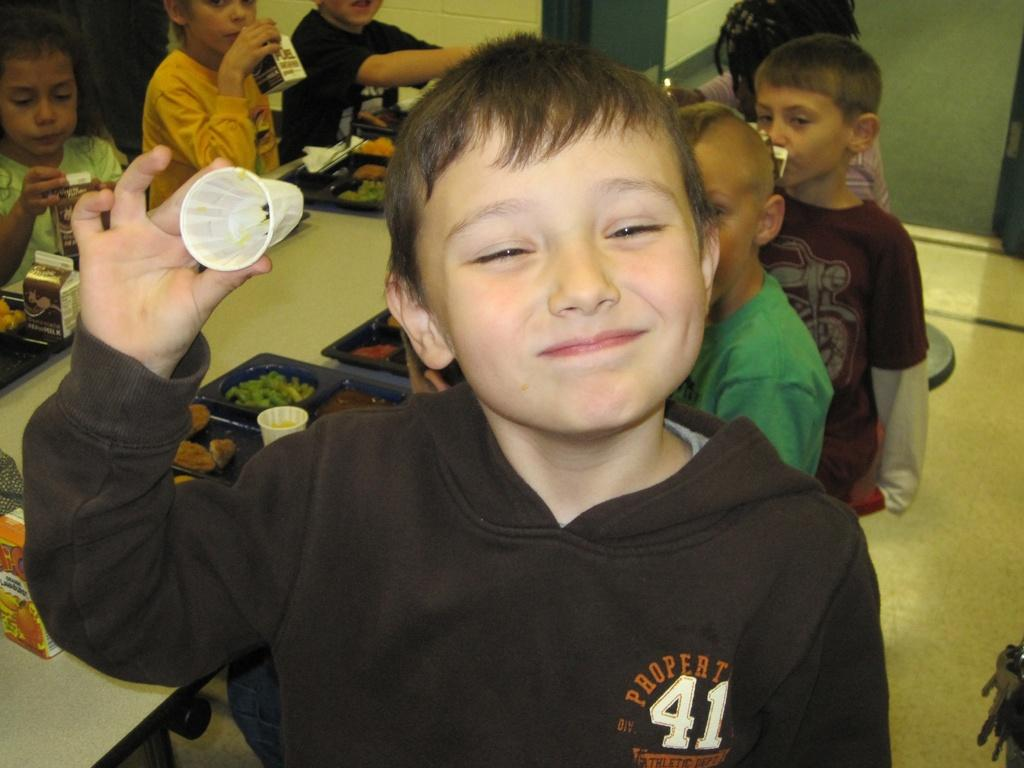What is happening in the room in the image? There are children in the room, and a boy is holding an object and posing for a photo. What can be found on the table in the room? There is a table with food items and other things in the room. What type of scarf is the boy wearing while driving in the image? There is no mention of driving or a scarf in the image, and the boy is not wearing a scarf. 